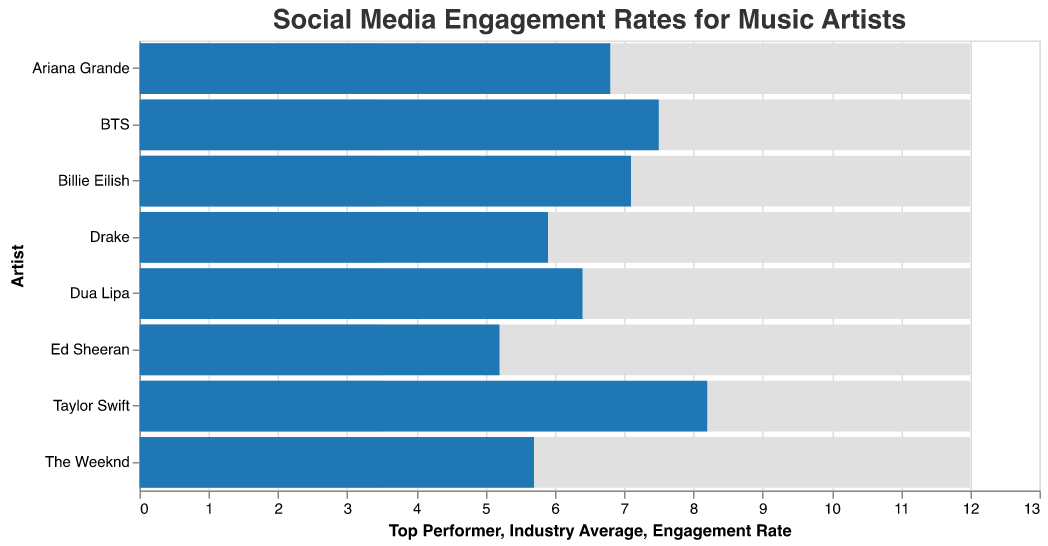Which artist has the highest engagement rate? By looking at the engagement rate bars, you can see that Taylor Swift has the highest engagement rate among the artists.
Answer: Taylor Swift How does Ariana Grande's engagement rate compare to the industry average? Ariana Grande's engagement rate bar is higher than the industry average bar. The engagement rate is 6.8 compared to the industry average of 3.5.
Answer: Higher Which artist has the lowest engagement rate, and what is it? By observing the engagement rate bars, you can see that Ed Sheeran has the lowest engagement rate among the artists, which is 5.2.
Answer: Ed Sheeran, 5.2 What's the difference between Billie Eilish's engagement rate and the top performer rate? Billie Eilish's engagement rate is 7.1, and the top performer rate is 12. By subtracting 7.1 from 12, the difference is 4.9.
Answer: 4.9 Which artists have engagement rates above both the industry average and below the top performer rate? The artists whose engagement rate bars are above 3.5 (industry average) but below 12 (top performer) are Taylor Swift, BTS, Ariana Grande, Billie Eilish, and Dua Lipa.
Answer: Taylor Swift, BTS, Ariana Grande, Billie Eilish, Dua Lipa Is The Weeknd's engagement rate closer to the industry average or the top performer rate? The Weeknd's engagement rate is 5.7. The distance to the industry average (3.5) is 2.2, while to the top performer rate (12) is 6.3. Since 2.2 is less than 6.3, it is closer to the industry average.
Answer: Industry Average By how much does Drake's engagement rate exceed the industry average? Drake's engagement rate is 5.9 while the industry average is 3.5. Subtracting these values gives 5.9 - 3.5 = 2.4.
Answer: 2.4 Which two artists have the closest engagement rates to each other? By comparing the engagement rate bars, BTS (7.5) and Billie Eilish (7.1) have rates that are closest to each other with a difference of 0.4.
Answer: BTS and Billie Eilish 